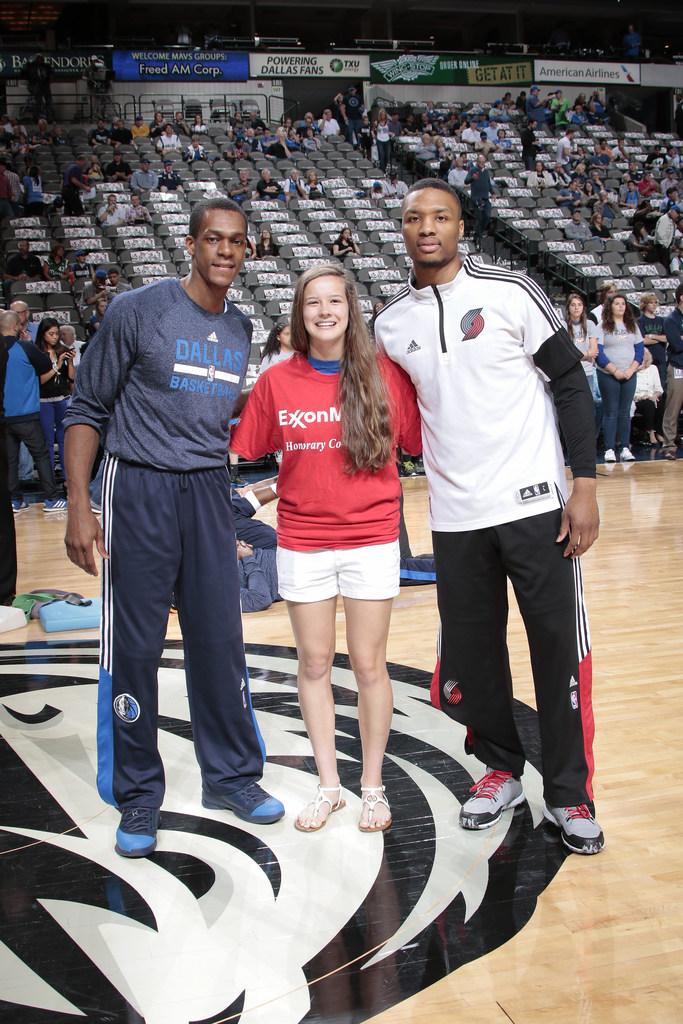Which brand is on the girl's shirt?
Offer a terse response. Exxon. 